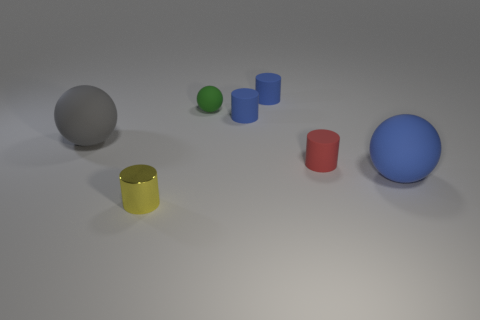Is the number of yellow cylinders behind the green rubber object the same as the number of large blue rubber things right of the big blue matte ball?
Give a very brief answer. Yes. What number of red objects are right of the tiny yellow cylinder in front of the big object that is to the left of the small red cylinder?
Provide a succinct answer. 1. There is a small ball; is its color the same as the tiny cylinder in front of the red rubber cylinder?
Ensure brevity in your answer.  No. Is the number of big blue rubber spheres to the right of the tiny ball greater than the number of blue matte spheres?
Give a very brief answer. No. What number of things are either tiny matte objects that are in front of the green matte object or balls that are to the right of the yellow thing?
Offer a terse response. 4. There is a red thing that is the same material as the gray thing; what is its size?
Provide a short and direct response. Small. Is the shape of the blue matte thing that is behind the green ball the same as  the gray object?
Provide a succinct answer. No. What number of purple objects are either rubber objects or tiny rubber blocks?
Your answer should be compact. 0. What number of other things are there of the same shape as the tiny yellow metallic thing?
Provide a short and direct response. 3. There is a object that is both to the right of the green matte thing and in front of the tiny red rubber thing; what is its shape?
Ensure brevity in your answer.  Sphere. 